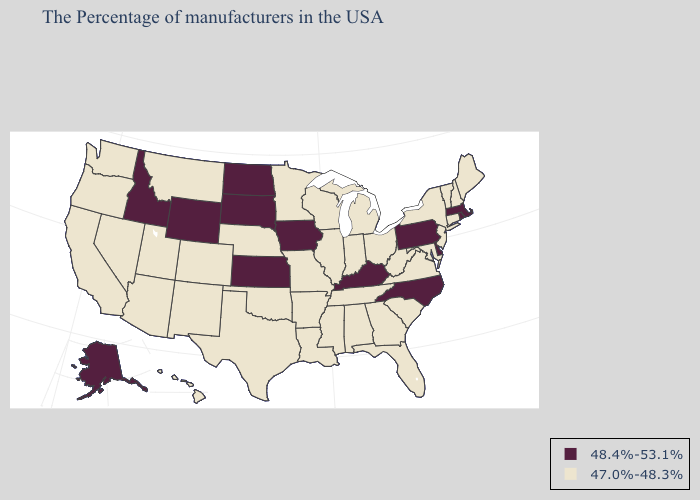Name the states that have a value in the range 47.0%-48.3%?
Write a very short answer. Maine, New Hampshire, Vermont, Connecticut, New York, New Jersey, Maryland, Virginia, South Carolina, West Virginia, Ohio, Florida, Georgia, Michigan, Indiana, Alabama, Tennessee, Wisconsin, Illinois, Mississippi, Louisiana, Missouri, Arkansas, Minnesota, Nebraska, Oklahoma, Texas, Colorado, New Mexico, Utah, Montana, Arizona, Nevada, California, Washington, Oregon, Hawaii. Name the states that have a value in the range 48.4%-53.1%?
Keep it brief. Massachusetts, Rhode Island, Delaware, Pennsylvania, North Carolina, Kentucky, Iowa, Kansas, South Dakota, North Dakota, Wyoming, Idaho, Alaska. What is the lowest value in states that border Georgia?
Be succinct. 47.0%-48.3%. Name the states that have a value in the range 48.4%-53.1%?
Concise answer only. Massachusetts, Rhode Island, Delaware, Pennsylvania, North Carolina, Kentucky, Iowa, Kansas, South Dakota, North Dakota, Wyoming, Idaho, Alaska. Does North Dakota have the highest value in the MidWest?
Be succinct. Yes. Does North Carolina have a higher value than Alaska?
Quick response, please. No. What is the value of Utah?
Give a very brief answer. 47.0%-48.3%. What is the value of Washington?
Answer briefly. 47.0%-48.3%. Does Wyoming have a higher value than Utah?
Keep it brief. Yes. What is the value of Pennsylvania?
Answer briefly. 48.4%-53.1%. What is the value of North Carolina?
Quick response, please. 48.4%-53.1%. Is the legend a continuous bar?
Short answer required. No. Name the states that have a value in the range 47.0%-48.3%?
Be succinct. Maine, New Hampshire, Vermont, Connecticut, New York, New Jersey, Maryland, Virginia, South Carolina, West Virginia, Ohio, Florida, Georgia, Michigan, Indiana, Alabama, Tennessee, Wisconsin, Illinois, Mississippi, Louisiana, Missouri, Arkansas, Minnesota, Nebraska, Oklahoma, Texas, Colorado, New Mexico, Utah, Montana, Arizona, Nevada, California, Washington, Oregon, Hawaii. Name the states that have a value in the range 47.0%-48.3%?
Be succinct. Maine, New Hampshire, Vermont, Connecticut, New York, New Jersey, Maryland, Virginia, South Carolina, West Virginia, Ohio, Florida, Georgia, Michigan, Indiana, Alabama, Tennessee, Wisconsin, Illinois, Mississippi, Louisiana, Missouri, Arkansas, Minnesota, Nebraska, Oklahoma, Texas, Colorado, New Mexico, Utah, Montana, Arizona, Nevada, California, Washington, Oregon, Hawaii. 